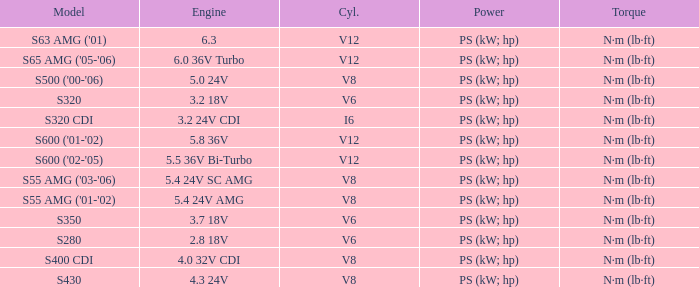Which torque is featured in a model of s63 amg ('01)? N·m (lb·ft). Could you help me parse every detail presented in this table? {'header': ['Model', 'Engine', 'Cyl.', 'Power', 'Torque'], 'rows': [["S63 AMG ('01)", '6.3', 'V12', 'PS (kW; hp)', 'N·m (lb·ft)'], ["S65 AMG ('05-'06)", '6.0 36V Turbo', 'V12', 'PS (kW; hp)', 'N·m (lb·ft)'], ["S500 ('00-'06)", '5.0 24V', 'V8', 'PS (kW; hp)', 'N·m (lb·ft)'], ['S320', '3.2 18V', 'V6', 'PS (kW; hp)', 'N·m (lb·ft)'], ['S320 CDI', '3.2 24V CDI', 'I6', 'PS (kW; hp)', 'N·m (lb·ft)'], ["S600 ('01-'02)", '5.8 36V', 'V12', 'PS (kW; hp)', 'N·m (lb·ft)'], ["S600 ('02-'05)", '5.5 36V Bi-Turbo', 'V12', 'PS (kW; hp)', 'N·m (lb·ft)'], ["S55 AMG ('03-'06)", '5.4 24V SC AMG', 'V8', 'PS (kW; hp)', 'N·m (lb·ft)'], ["S55 AMG ('01-'02)", '5.4 24V AMG', 'V8', 'PS (kW; hp)', 'N·m (lb·ft)'], ['S350', '3.7 18V', 'V6', 'PS (kW; hp)', 'N·m (lb·ft)'], ['S280', '2.8 18V', 'V6', 'PS (kW; hp)', 'N·m (lb·ft)'], ['S400 CDI', '4.0 32V CDI', 'V8', 'PS (kW; hp)', 'N·m (lb·ft)'], ['S430', '4.3 24V', 'V8', 'PS (kW; hp)', 'N·m (lb·ft)']]} 